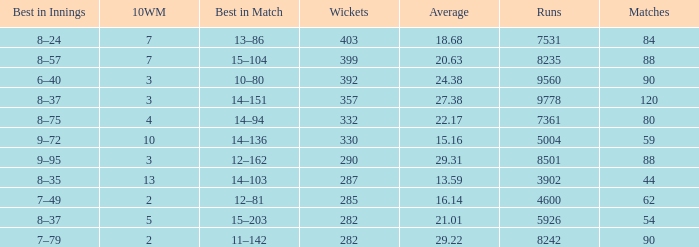What is the total number of runs connected with 10wm values exceeding 13? None. 